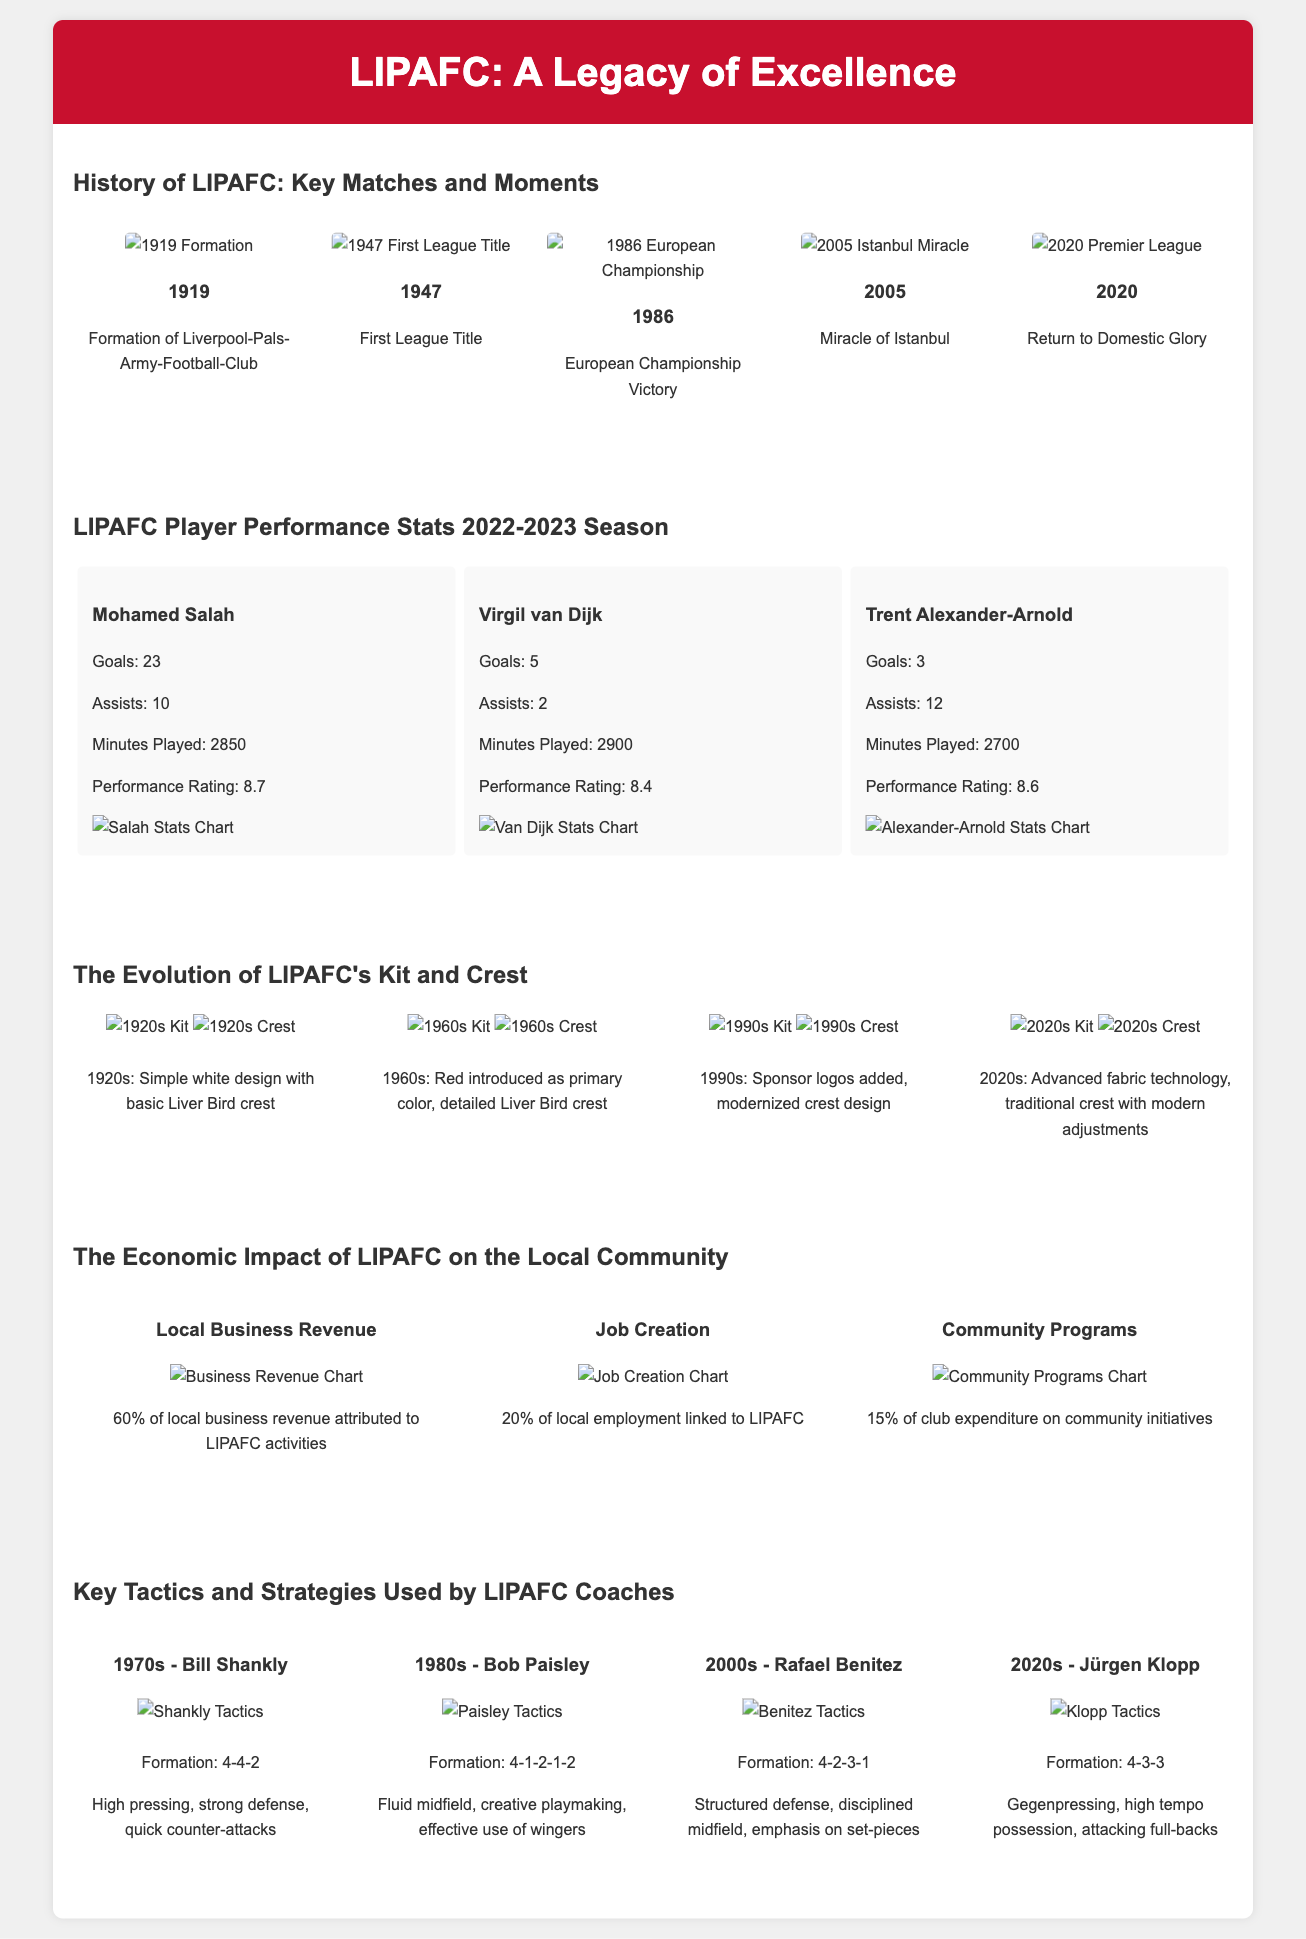What year was the Liverpool-Pals-Army-Football-Club formed? The formation year of LIPAFC is directly mentioned in the timeline section.
Answer: 1919 What was the performance rating of Mohamed Salah? The performance rating is presented under the player stats section for Mohamed Salah.
Answer: 8.7 Which formation did Bill Shankly use in the 1970s? The formation used by Bill Shankly is stated in the tactics section related to that era.
Answer: 4-4-2 What percentage of local business revenue is attributed to LIPAFC activities? This percentage is provided in the economic impact section regarding local business revenue.
Answer: 60% What significant event occurred for LIPAFC in 2005? The event is mentioned in the timeline of key matches and moments for the year 2005.
Answer: Miracle of Istanbul Which player had the most assists in the 2022-2023 season? The player with the most assists is specified in the player performance stats section.
Answer: Trent Alexander-Arnold What color was introduced as the primary color of LIPAFC's kit in the 1960s? This detail is included in the evolution section of the club's kit and crest.
Answer: Red What formation did Jürgen Klopp use in the 2020s? The formation used by Jürgen Klopp is indicated in the tactics section related to that era.
Answer: 4-3-3 How many community programs did LIPAFC fund according to the infographic? The percentage of club expenditure on community programs is provided in the economic impact section.
Answer: 15% 